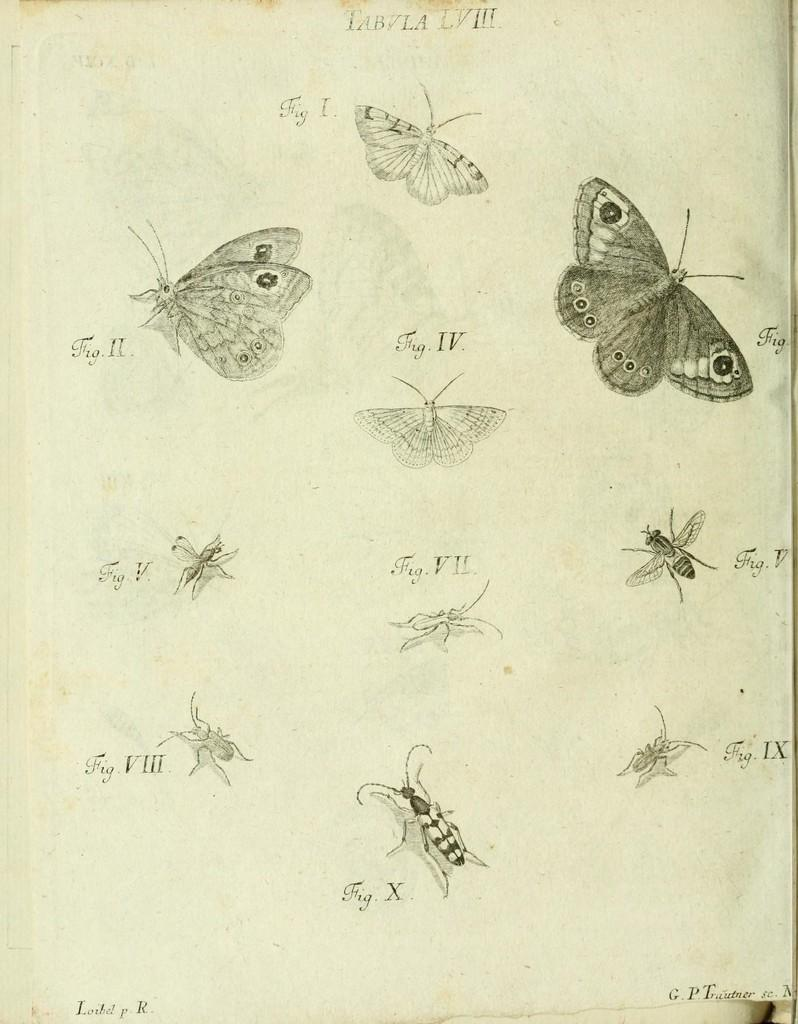What is present on the paper in the image? The paper contains drawings of butterflies and text. Can you describe the drawings on the paper? The drawings on the paper are of butterflies. What else can be found on the paper besides the drawings? There is text on the paper. What type of pain is being expressed by the butterflies in the image? There is no indication of pain or emotion in the butterflies' drawings in the image. 